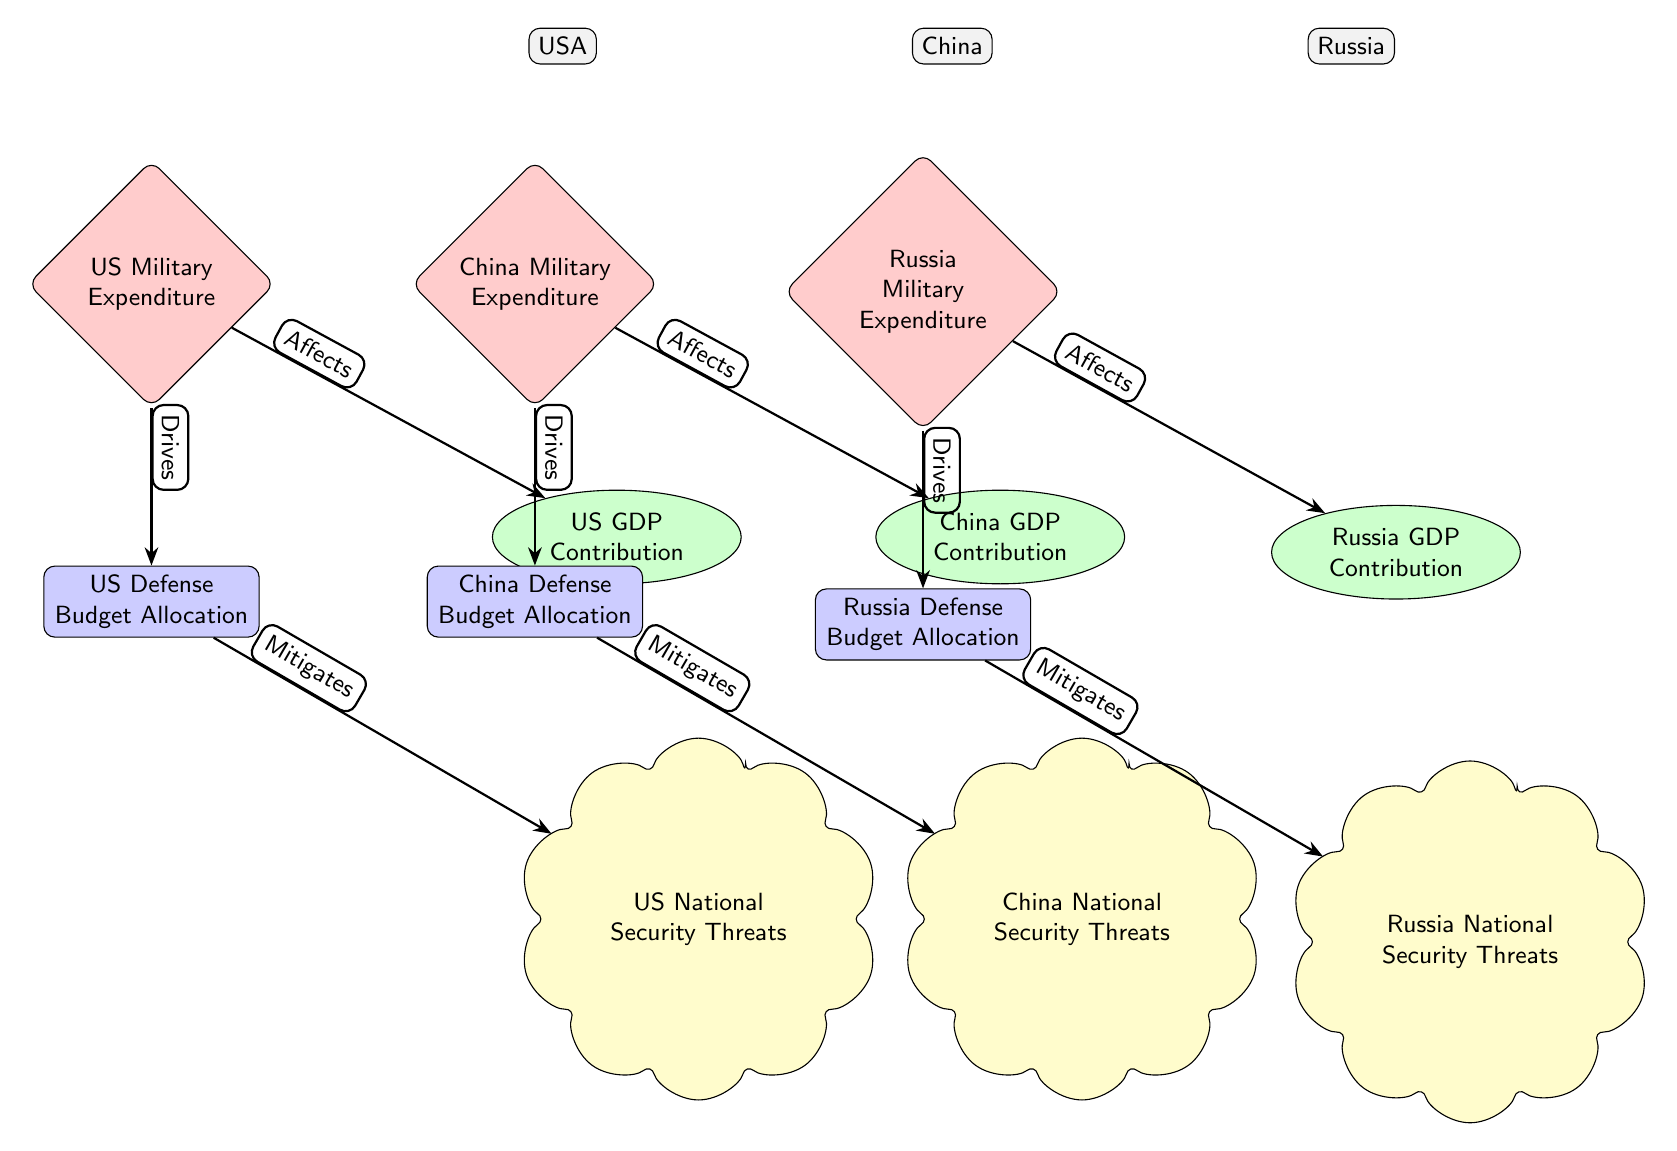What country is associated with the highest military expenditure? The diagram shows three countries: the USA, China, and Russia. Each country node is connected to a military expenditure node. However, the diagram does not provide specific values, but the USA is traditionally known to have the highest military expenditure globally.
Answer: USA What type of relationship exists between military expenditure and GDP contribution? In the diagram, each military expenditure node is connected to its respective GDP contribution node with the label "Affects." This indicates a direct influence or relationship where military expenditure impacts GDP contribution.
Answer: Affects How many countries are represented in the diagram? The diagram features three countries—USA, China, and Russia—each represented by a node. Counting these nodes provides the total number of countries depicted.
Answer: 3 What drives the defense budget allocation in China? The diagram indicates that military expenditure in China "Drives" the defense budget allocation. This shows that the level of military spending influences how the budget for defense is determined in China.
Answer: Military Expenditure Which country has the node labeled 'National Security Threats' connected to its defense budget allocation? The diagram shows that each country (USA, China, and Russia) has a 'National Security Threats' node connected to its corresponding 'Defense Budget Allocation' node with the label "Mitigates." This implies that for each country, their defense budget aims to address these threats.
Answer: All countries (USA, China, Russia) Does increased military expenditure lead to a higher national security threat level? The diagram outlines that military expenditure affects GDP contribution and drives defense budget allocation, which in turn mitigates national security threats. This indicates that while increased military spending does not directly lead to higher threats, it aims to counteract them.
Answer: No Which node follows the relationship "Mitigates" in the USA section? In the USA section, the 'Defense Budget Allocation' node is linked to the 'National Security Threats' node through the "Mitigates" label. This indicates that the defense budget allocation works to reduce or alleviate security threats.
Answer: National Security Threats What color represents the GDP contribution nodes in the diagram? The GDP contribution nodes for each country (USA, China, and Russia) are represented with an ellipse shape and filled with a light green color, as indicated by the diagram's styling conventions.
Answer: Green What is a unique feature of the diagram regarding the types of relationships? The diagram clearly distinguishes relationships by labeling them for each connection, such as "Affects," "Drives," and "Mitigates," emphasizing the causal connections between military expenditure, budget allocation, and threat levels.
Answer: Labeled relationships 